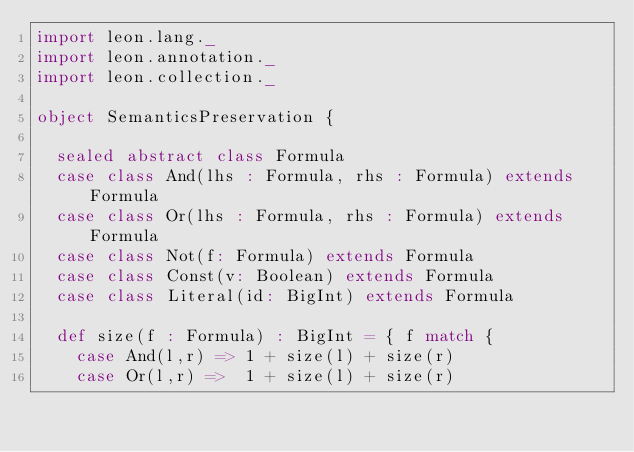<code> <loc_0><loc_0><loc_500><loc_500><_Scala_>import leon.lang._
import leon.annotation._
import leon.collection._

object SemanticsPreservation { 

  sealed abstract class Formula
  case class And(lhs : Formula, rhs : Formula) extends Formula
  case class Or(lhs : Formula, rhs : Formula) extends Formula
  case class Not(f: Formula) extends Formula
  case class Const(v: Boolean) extends Formula
  case class Literal(id: BigInt) extends Formula

  def size(f : Formula) : BigInt = { f match {
    case And(l,r) => 1 + size(l) + size(r)
    case Or(l,r) =>  1 + size(l) + size(r)</code> 